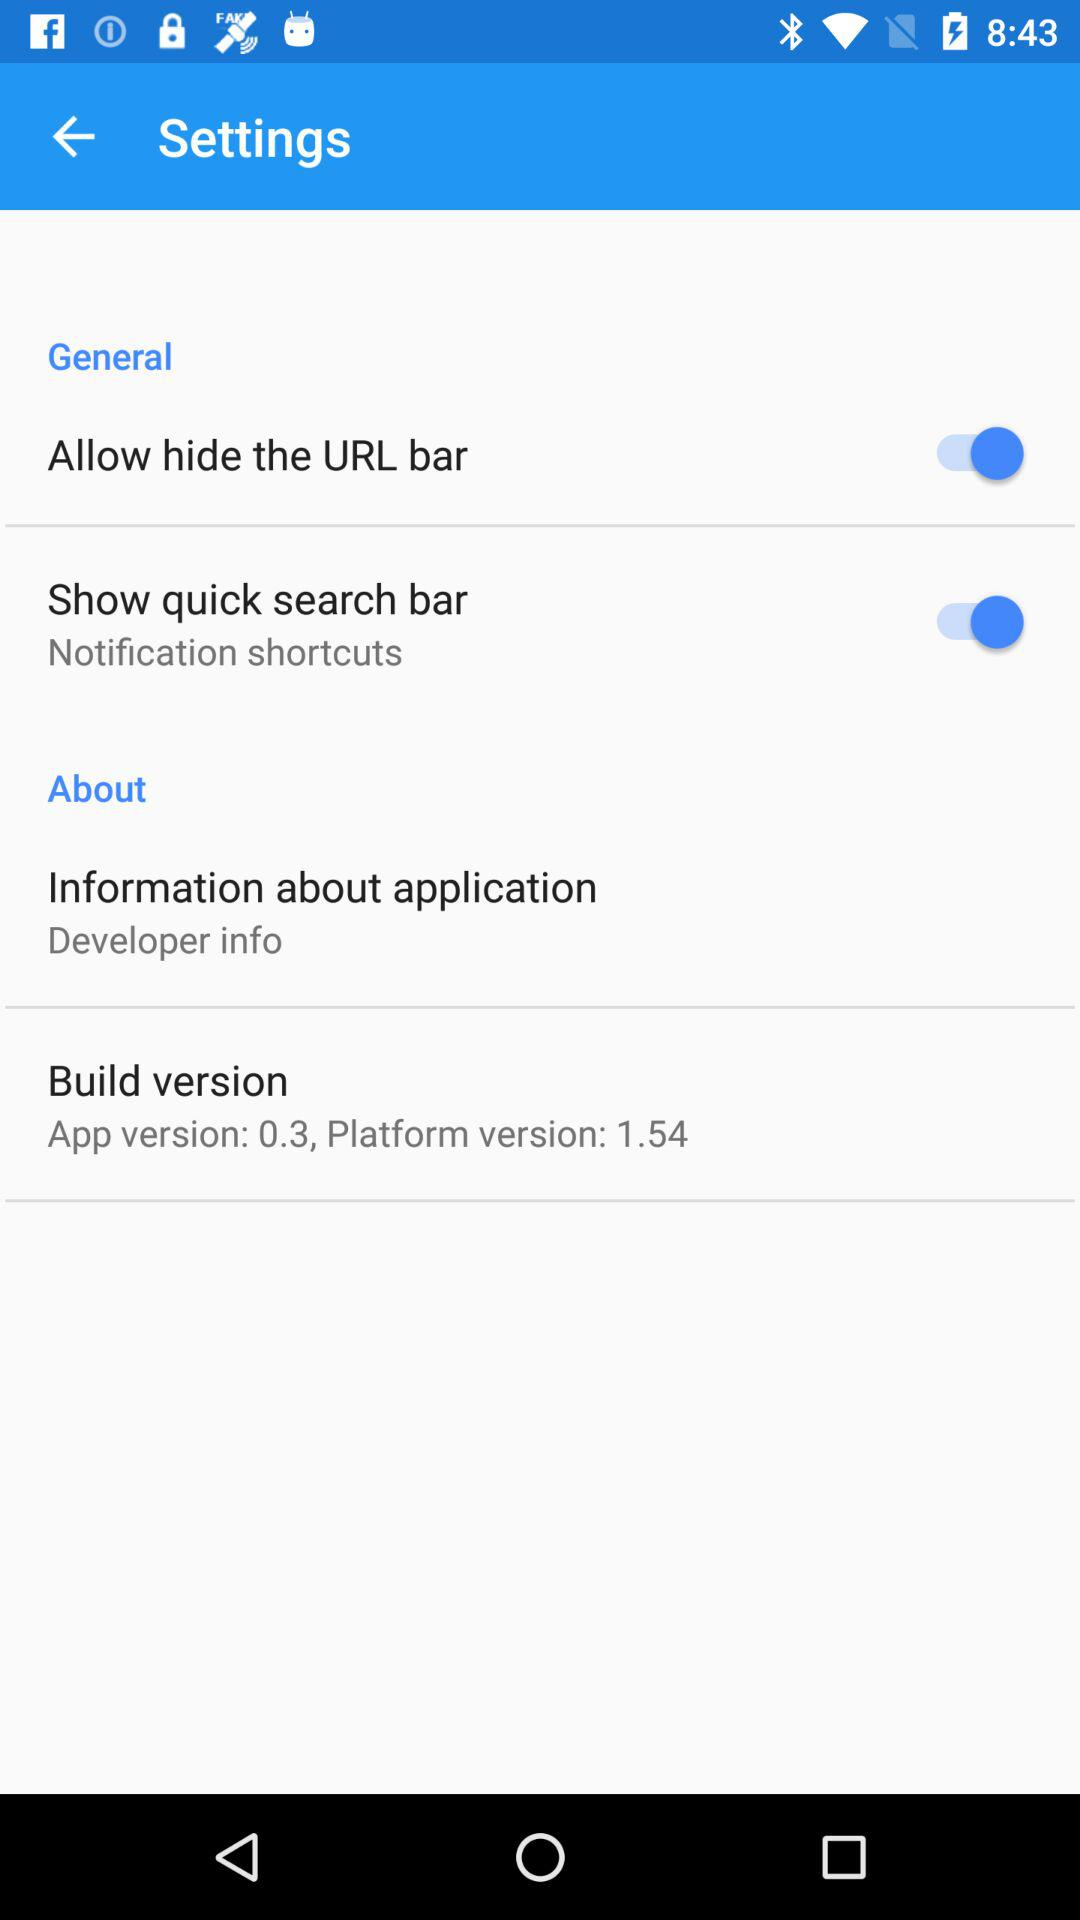What is the status of "Show quick search bar"? The status of "Show quick search bar" is "on". 